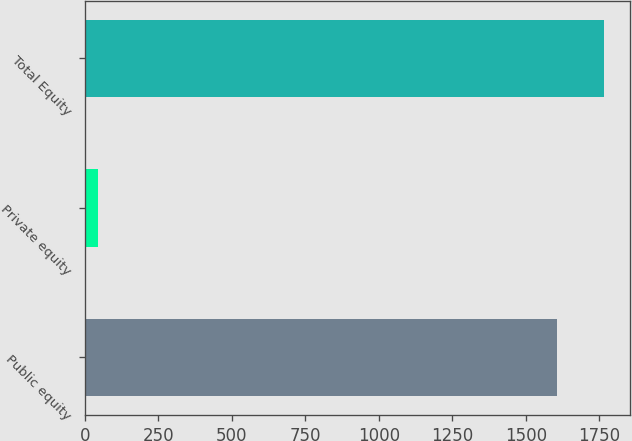<chart> <loc_0><loc_0><loc_500><loc_500><bar_chart><fcel>Public equity<fcel>Private equity<fcel>Total Equity<nl><fcel>1605<fcel>44<fcel>1765.5<nl></chart> 